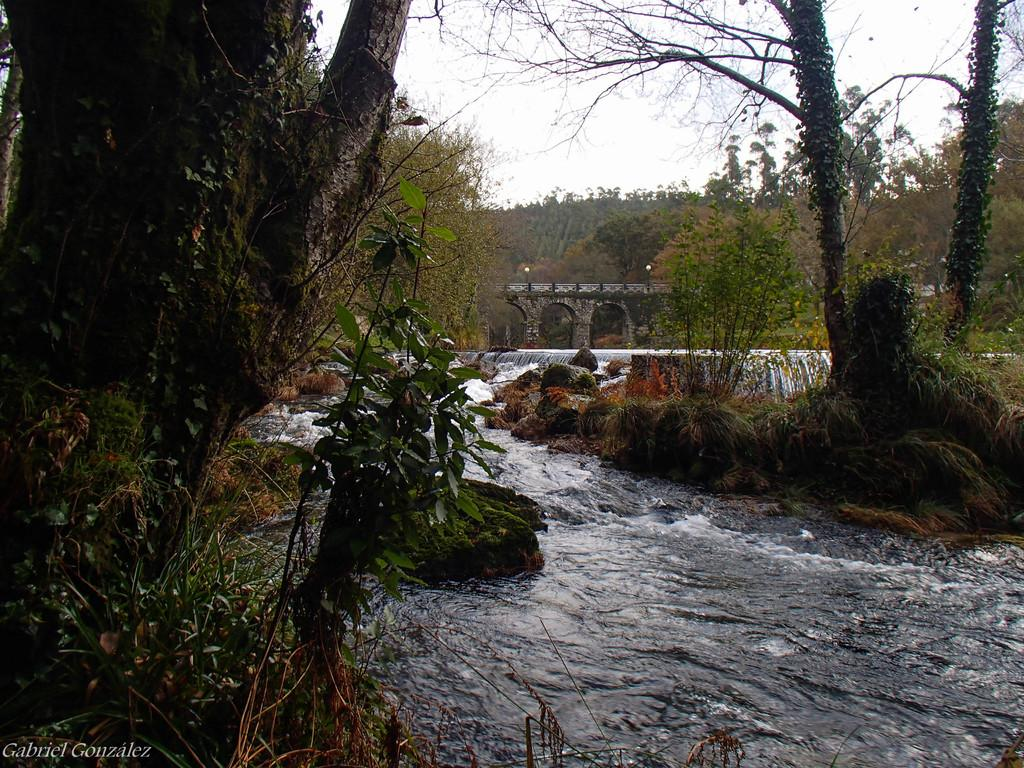What is visible in the image? There is water visible in the image. What can be seen in the background of the image? There are stones and trees with green color in the background of the image. What structure is present in the image? There is a bridge in the image. What is the color of the sky in the image? The sky appears to be white in color. What type of tin can be seen on the bridge in the image? There is no tin present on the bridge or in the image. What sound does the alarm make in the image? There is no alarm present in the image. 